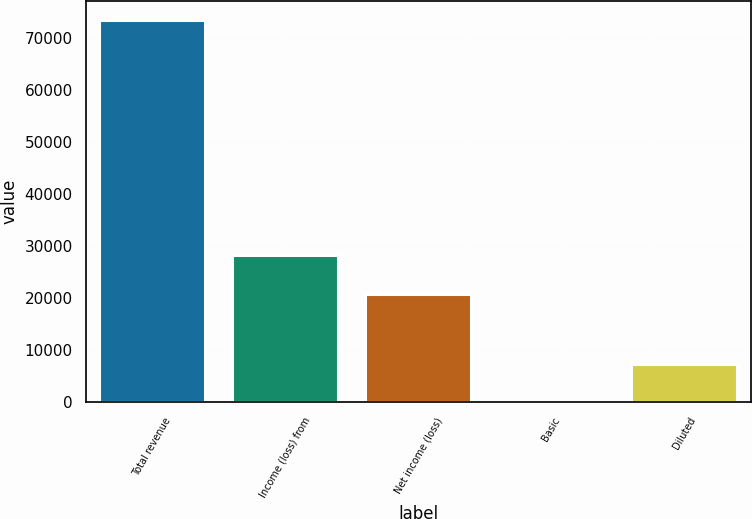<chart> <loc_0><loc_0><loc_500><loc_500><bar_chart><fcel>Total revenue<fcel>Income (loss) from<fcel>Net income (loss)<fcel>Basic<fcel>Diluted<nl><fcel>73501<fcel>28224.1<fcel>20874<fcel>0.26<fcel>7350.33<nl></chart> 